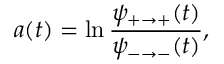Convert formula to latex. <formula><loc_0><loc_0><loc_500><loc_500>a ( t ) = \ln \frac { \psi _ { + \to + } ( t ) } { \psi _ { - \to - } ( t ) } ,</formula> 